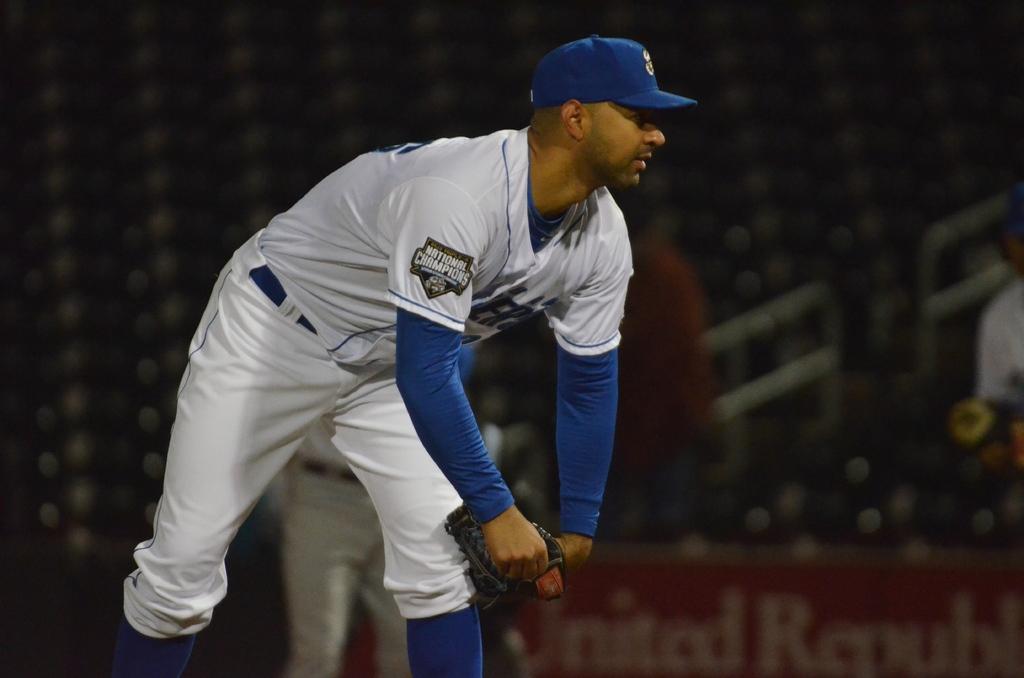What does the patch on this player's upper arm say?
Your answer should be compact. National champions. What is the first word on the sign say?
Your answer should be compact. United. 